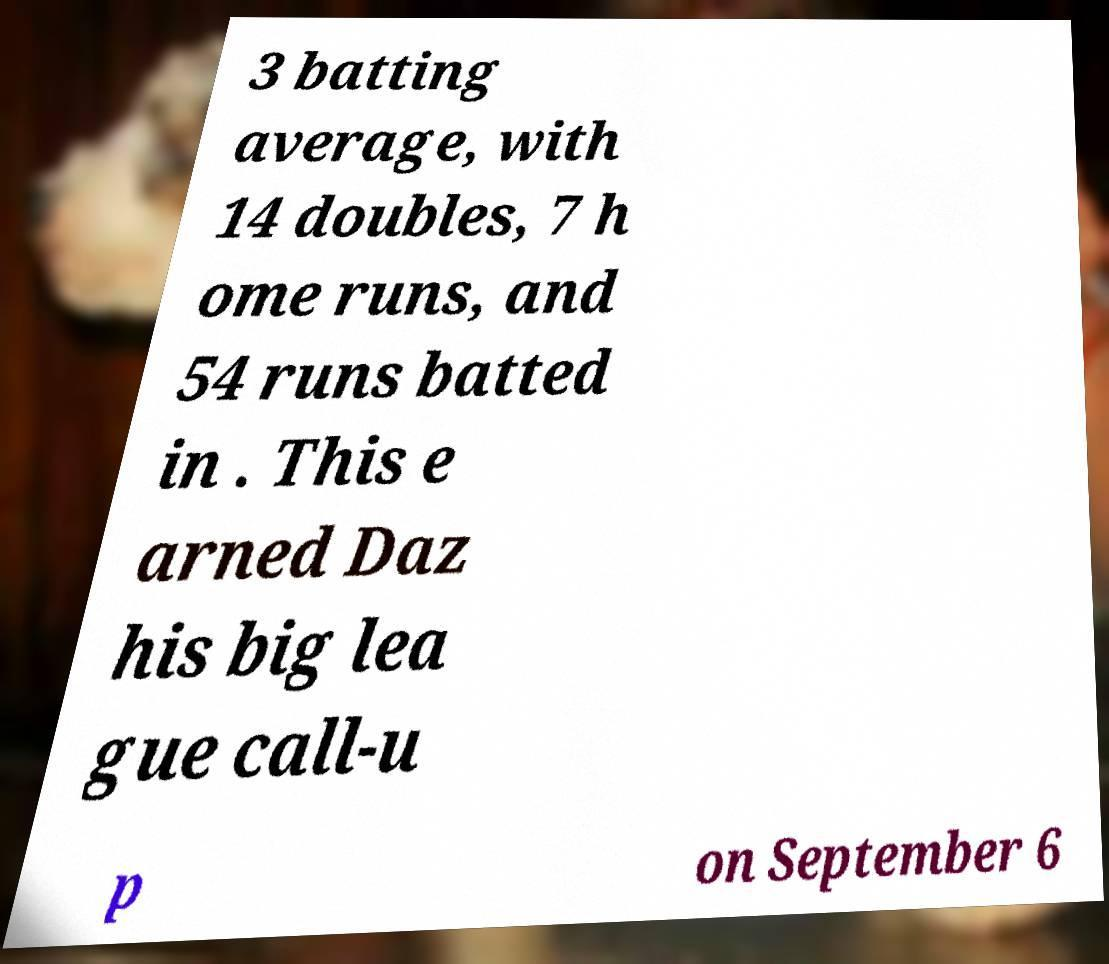Can you accurately transcribe the text from the provided image for me? 3 batting average, with 14 doubles, 7 h ome runs, and 54 runs batted in . This e arned Daz his big lea gue call-u p on September 6 